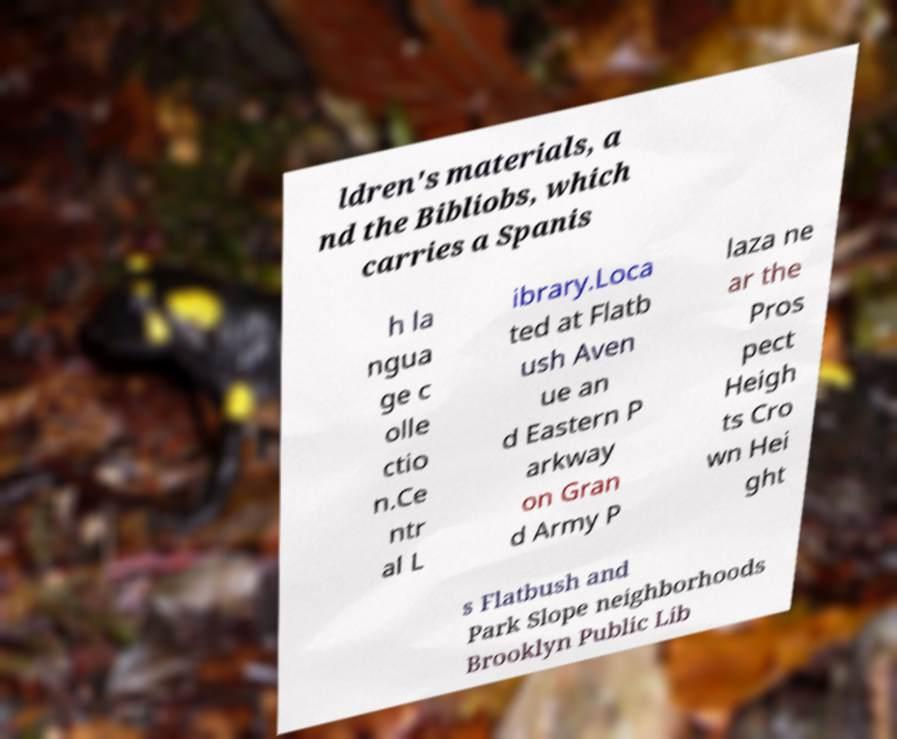Can you read and provide the text displayed in the image?This photo seems to have some interesting text. Can you extract and type it out for me? ldren's materials, a nd the Bibliobs, which carries a Spanis h la ngua ge c olle ctio n.Ce ntr al L ibrary.Loca ted at Flatb ush Aven ue an d Eastern P arkway on Gran d Army P laza ne ar the Pros pect Heigh ts Cro wn Hei ght s Flatbush and Park Slope neighborhoods Brooklyn Public Lib 